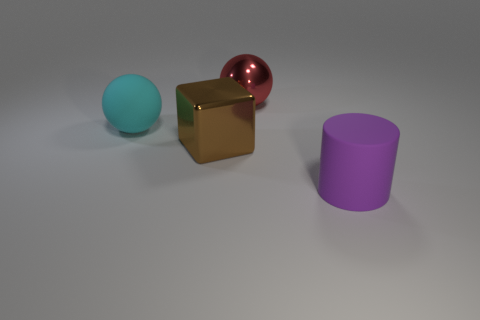Subtract all green balls. Subtract all brown blocks. How many balls are left? 2 Add 1 cyan rubber things. How many objects exist? 5 Subtract all cylinders. How many objects are left? 3 Add 1 red metallic balls. How many red metallic balls are left? 2 Add 1 big cyan rubber spheres. How many big cyan rubber spheres exist? 2 Subtract 1 cyan balls. How many objects are left? 3 Subtract all shiny cubes. Subtract all large purple cylinders. How many objects are left? 2 